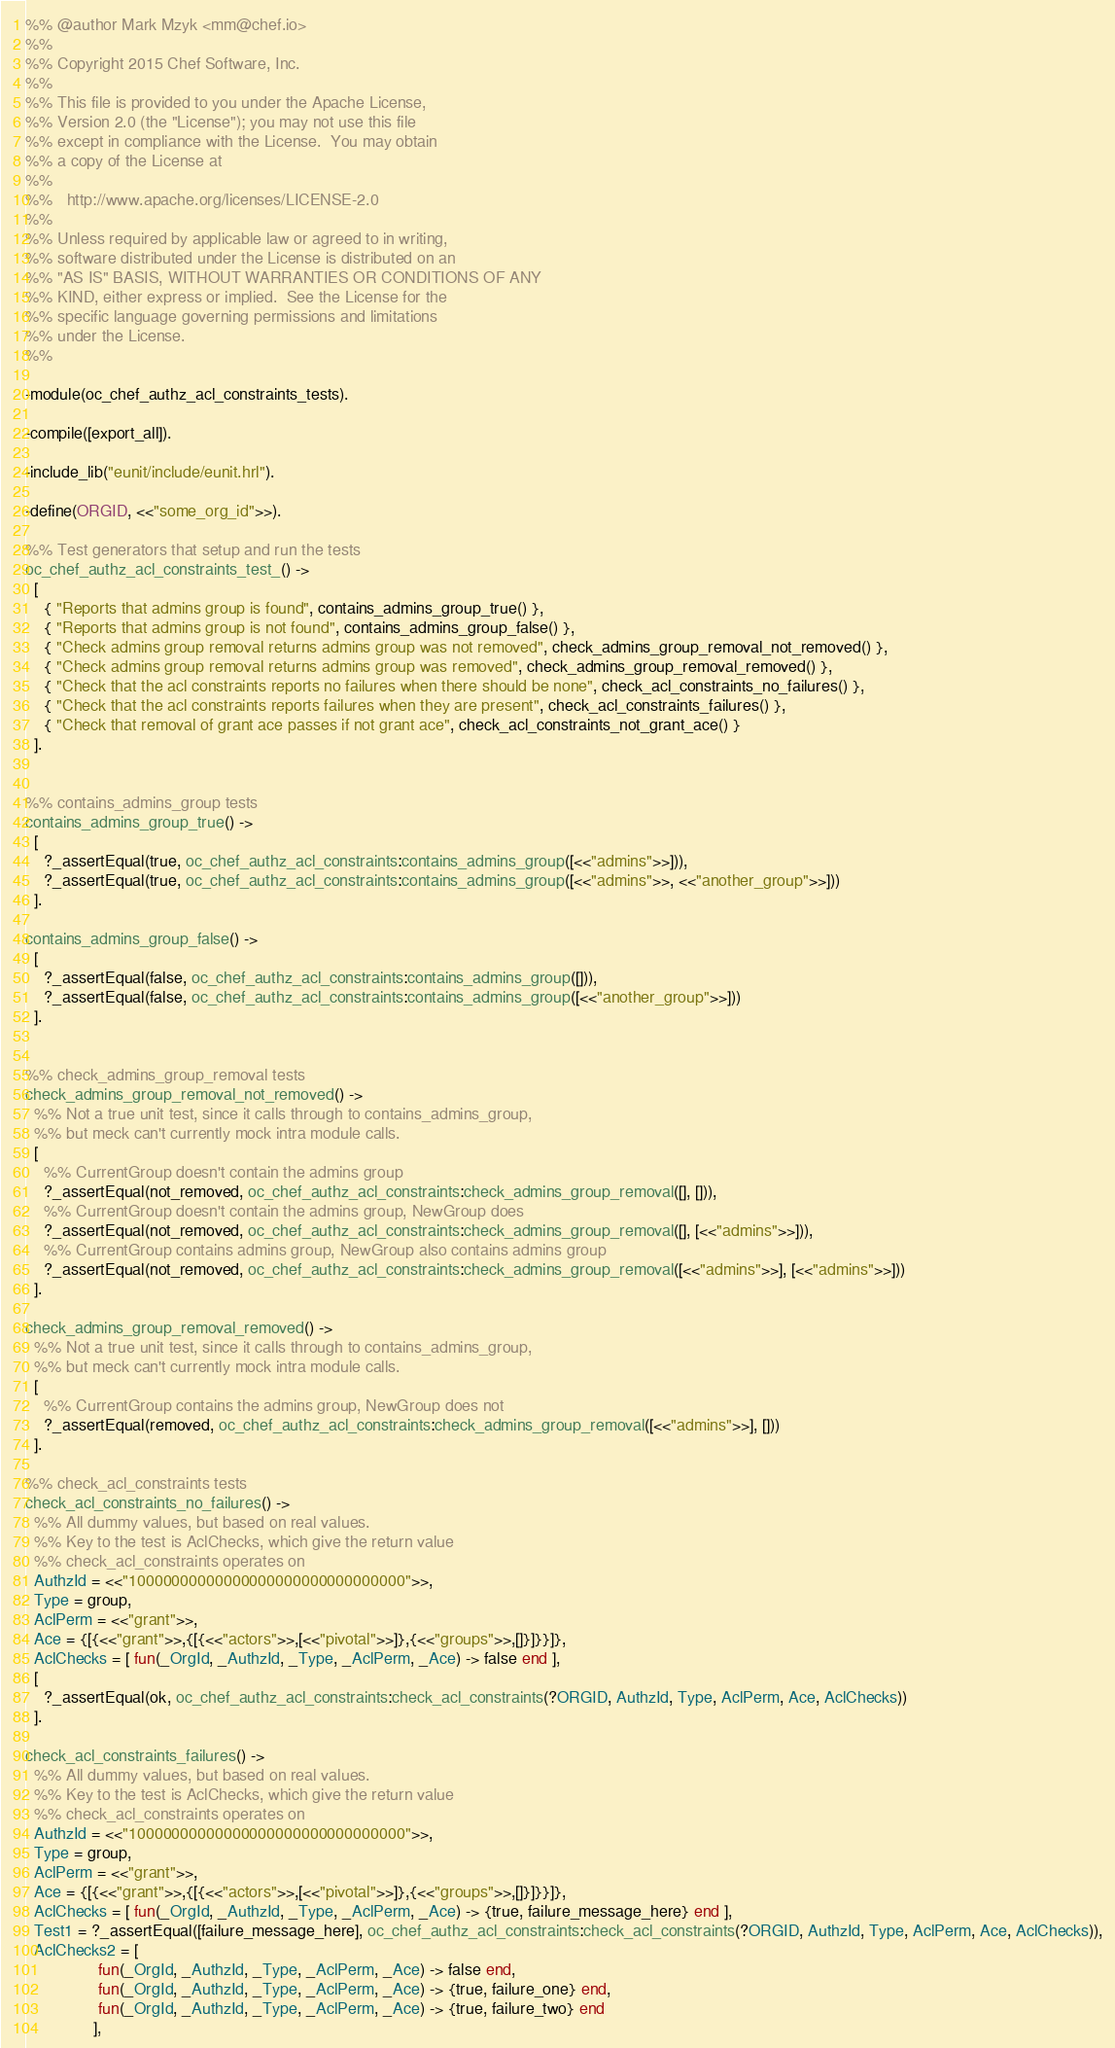Convert code to text. <code><loc_0><loc_0><loc_500><loc_500><_Erlang_>%% @author Mark Mzyk <mm@chef.io>
%%
%% Copyright 2015 Chef Software, Inc.
%%
%% This file is provided to you under the Apache License,
%% Version 2.0 (the "License"); you may not use this file
%% except in compliance with the License.  You may obtain
%% a copy of the License at
%%
%%   http://www.apache.org/licenses/LICENSE-2.0
%%
%% Unless required by applicable law or agreed to in writing,
%% software distributed under the License is distributed on an
%% "AS IS" BASIS, WITHOUT WARRANTIES OR CONDITIONS OF ANY
%% KIND, either express or implied.  See the License for the
%% specific language governing permissions and limitations
%% under the License.
%%

-module(oc_chef_authz_acl_constraints_tests).

-compile([export_all]).

-include_lib("eunit/include/eunit.hrl").

-define(ORGID, <<"some_org_id">>).

%% Test generators that setup and run the tests
oc_chef_authz_acl_constraints_test_() ->
  [
    { "Reports that admins group is found", contains_admins_group_true() },
    { "Reports that admins group is not found", contains_admins_group_false() },
    { "Check admins group removal returns admins group was not removed", check_admins_group_removal_not_removed() },
    { "Check admins group removal returns admins group was removed", check_admins_group_removal_removed() },
    { "Check that the acl constraints reports no failures when there should be none", check_acl_constraints_no_failures() },
    { "Check that the acl constraints reports failures when they are present", check_acl_constraints_failures() },
    { "Check that removal of grant ace passes if not grant ace", check_acl_constraints_not_grant_ace() }
  ].


%% contains_admins_group tests
contains_admins_group_true() ->
  [
    ?_assertEqual(true, oc_chef_authz_acl_constraints:contains_admins_group([<<"admins">>])),
    ?_assertEqual(true, oc_chef_authz_acl_constraints:contains_admins_group([<<"admins">>, <<"another_group">>]))
  ].

contains_admins_group_false() ->
  [
    ?_assertEqual(false, oc_chef_authz_acl_constraints:contains_admins_group([])),
    ?_assertEqual(false, oc_chef_authz_acl_constraints:contains_admins_group([<<"another_group">>]))
  ].


%% check_admins_group_removal tests
check_admins_group_removal_not_removed() ->
  %% Not a true unit test, since it calls through to contains_admins_group,
  %% but meck can't currently mock intra module calls.
  [
    %% CurrentGroup doesn't contain the admins group
    ?_assertEqual(not_removed, oc_chef_authz_acl_constraints:check_admins_group_removal([], [])),
    %% CurrentGroup doesn't contain the admins group, NewGroup does
    ?_assertEqual(not_removed, oc_chef_authz_acl_constraints:check_admins_group_removal([], [<<"admins">>])),
    %% CurrentGroup contains admins group, NewGroup also contains admins group
    ?_assertEqual(not_removed, oc_chef_authz_acl_constraints:check_admins_group_removal([<<"admins">>], [<<"admins">>]))
  ].

check_admins_group_removal_removed() ->
  %% Not a true unit test, since it calls through to contains_admins_group,
  %% but meck can't currently mock intra module calls.
  [
    %% CurrentGroup contains the admins group, NewGroup does not
    ?_assertEqual(removed, oc_chef_authz_acl_constraints:check_admins_group_removal([<<"admins">>], []))
  ].

%% check_acl_constraints tests
check_acl_constraints_no_failures() ->
  %% All dummy values, but based on real values.
  %% Key to the test is AclChecks, which give the return value
  %% check_acl_constraints operates on
  AuthzId = <<"10000000000000000000000000000000">>,
  Type = group,
  AclPerm = <<"grant">>,
  Ace = {[{<<"grant">>,{[{<<"actors">>,[<<"pivotal">>]},{<<"groups">>,[]}]}}]},
  AclChecks = [ fun(_OrgId, _AuthzId, _Type, _AclPerm, _Ace) -> false end ],
  [
    ?_assertEqual(ok, oc_chef_authz_acl_constraints:check_acl_constraints(?ORGID, AuthzId, Type, AclPerm, Ace, AclChecks))
  ].

check_acl_constraints_failures() ->
  %% All dummy values, but based on real values.
  %% Key to the test is AclChecks, which give the return value
  %% check_acl_constraints operates on
  AuthzId = <<"10000000000000000000000000000000">>,
  Type = group,
  AclPerm = <<"grant">>,
  Ace = {[{<<"grant">>,{[{<<"actors">>,[<<"pivotal">>]},{<<"groups">>,[]}]}}]},
  AclChecks = [ fun(_OrgId, _AuthzId, _Type, _AclPerm, _Ace) -> {true, failure_message_here} end ],
  Test1 = ?_assertEqual([failure_message_here], oc_chef_authz_acl_constraints:check_acl_constraints(?ORGID, AuthzId, Type, AclPerm, Ace, AclChecks)),
  AclChecks2 = [
                fun(_OrgId, _AuthzId, _Type, _AclPerm, _Ace) -> false end,
                fun(_OrgId, _AuthzId, _Type, _AclPerm, _Ace) -> {true, failure_one} end,
                fun(_OrgId, _AuthzId, _Type, _AclPerm, _Ace) -> {true, failure_two} end
               ],</code> 